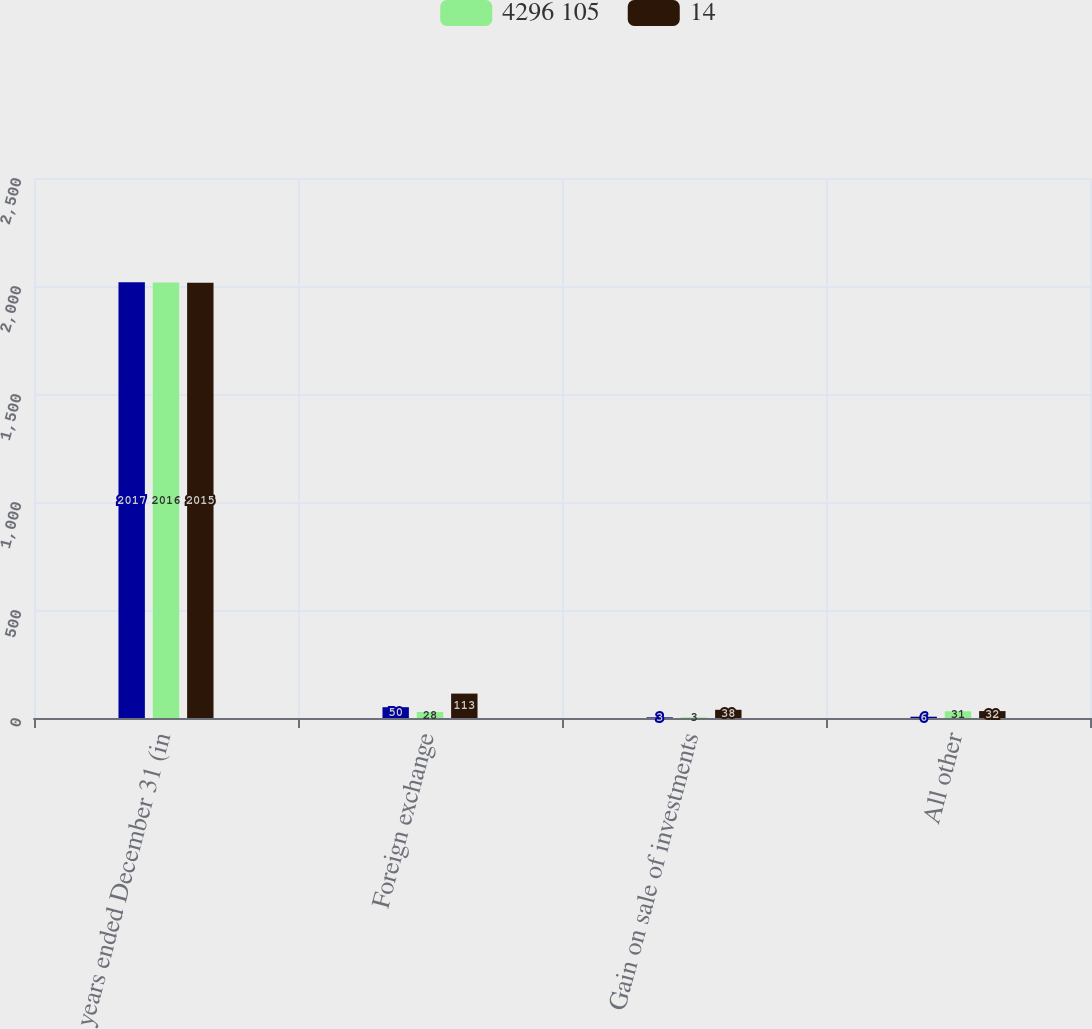Convert chart to OTSL. <chart><loc_0><loc_0><loc_500><loc_500><stacked_bar_chart><ecel><fcel>years ended December 31 (in<fcel>Foreign exchange<fcel>Gain on sale of investments<fcel>All other<nl><fcel>nan<fcel>2017<fcel>50<fcel>3<fcel>6<nl><fcel>4296 105<fcel>2016<fcel>28<fcel>3<fcel>31<nl><fcel>14<fcel>2015<fcel>113<fcel>38<fcel>32<nl></chart> 